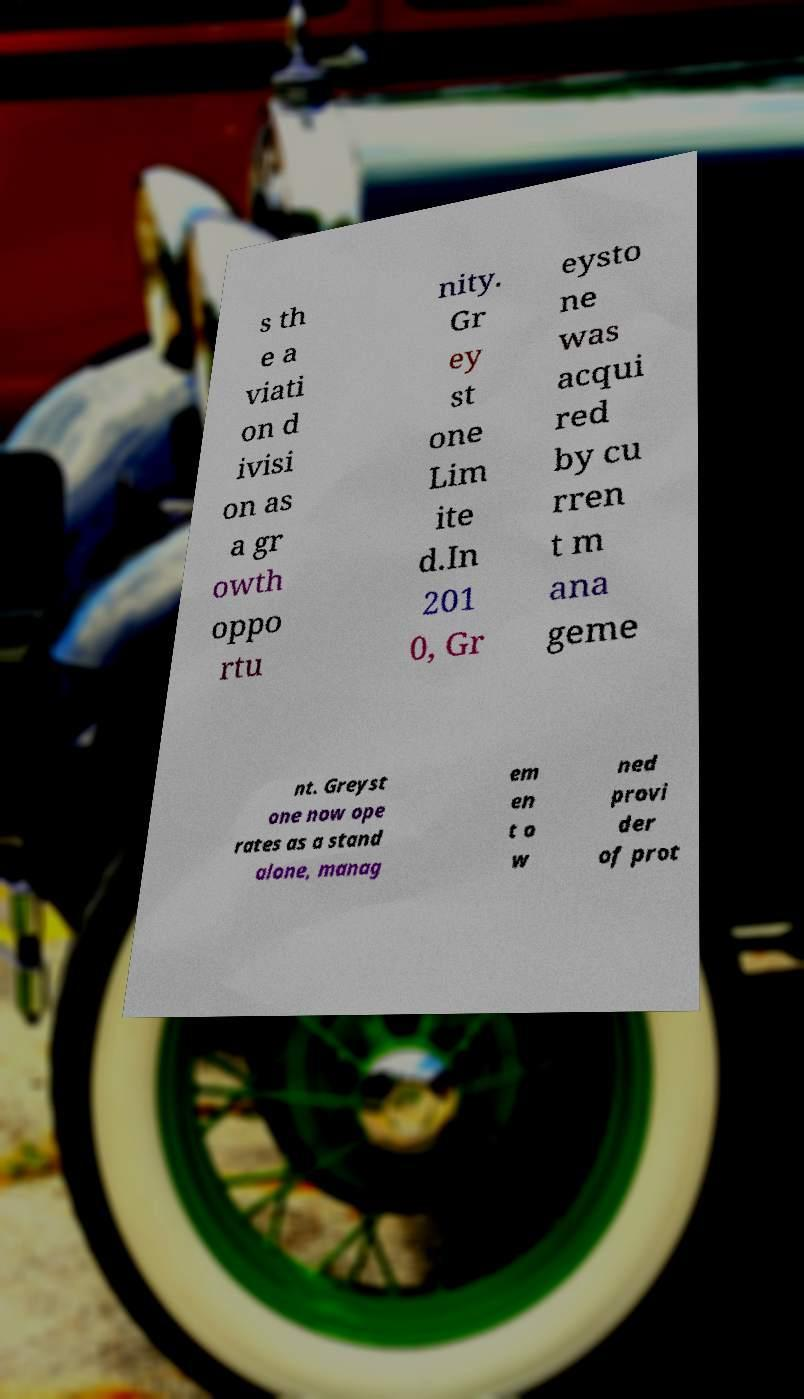Could you assist in decoding the text presented in this image and type it out clearly? s th e a viati on d ivisi on as a gr owth oppo rtu nity. Gr ey st one Lim ite d.In 201 0, Gr eysto ne was acqui red by cu rren t m ana geme nt. Greyst one now ope rates as a stand alone, manag em en t o w ned provi der of prot 